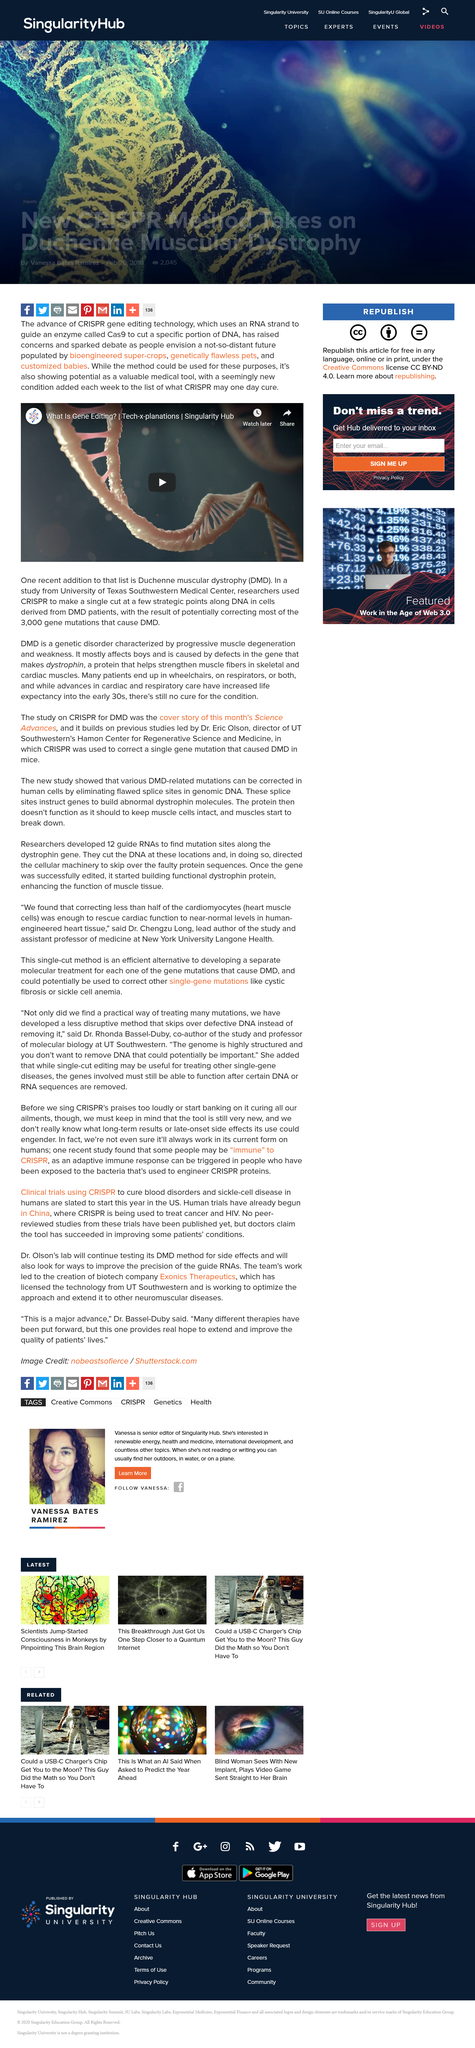Give some essential details in this illustration. Yes, CRISPR gene editing technology is a current and widely used technology. Recently, Duchenne muscular dystrophy (DMD) has been added to the list of diseases that may one day be cured by CRISPR. 